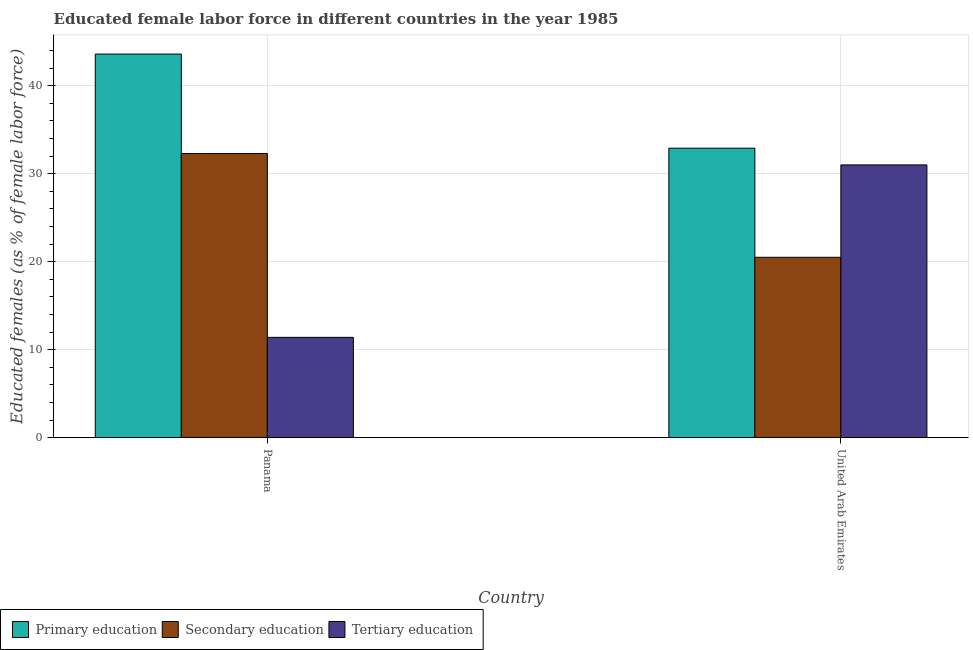How many different coloured bars are there?
Provide a short and direct response. 3. Are the number of bars on each tick of the X-axis equal?
Give a very brief answer. Yes. How many bars are there on the 1st tick from the right?
Ensure brevity in your answer.  3. What is the label of the 2nd group of bars from the left?
Give a very brief answer. United Arab Emirates. What is the percentage of female labor force who received primary education in United Arab Emirates?
Your answer should be very brief. 32.9. Across all countries, what is the maximum percentage of female labor force who received secondary education?
Your answer should be very brief. 32.3. Across all countries, what is the minimum percentage of female labor force who received tertiary education?
Provide a succinct answer. 11.4. In which country was the percentage of female labor force who received secondary education maximum?
Offer a very short reply. Panama. In which country was the percentage of female labor force who received primary education minimum?
Make the answer very short. United Arab Emirates. What is the total percentage of female labor force who received tertiary education in the graph?
Provide a succinct answer. 42.4. What is the difference between the percentage of female labor force who received tertiary education in Panama and that in United Arab Emirates?
Make the answer very short. -19.6. What is the difference between the percentage of female labor force who received secondary education in United Arab Emirates and the percentage of female labor force who received primary education in Panama?
Offer a terse response. -23.1. What is the average percentage of female labor force who received primary education per country?
Give a very brief answer. 38.25. In how many countries, is the percentage of female labor force who received primary education greater than 30 %?
Ensure brevity in your answer.  2. What is the ratio of the percentage of female labor force who received secondary education in Panama to that in United Arab Emirates?
Make the answer very short. 1.58. What does the 3rd bar from the left in United Arab Emirates represents?
Give a very brief answer. Tertiary education. What does the 2nd bar from the right in United Arab Emirates represents?
Provide a short and direct response. Secondary education. How many countries are there in the graph?
Offer a terse response. 2. What is the difference between two consecutive major ticks on the Y-axis?
Your answer should be compact. 10. Are the values on the major ticks of Y-axis written in scientific E-notation?
Ensure brevity in your answer.  No. Does the graph contain any zero values?
Offer a very short reply. No. Where does the legend appear in the graph?
Make the answer very short. Bottom left. How are the legend labels stacked?
Keep it short and to the point. Horizontal. What is the title of the graph?
Provide a short and direct response. Educated female labor force in different countries in the year 1985. What is the label or title of the Y-axis?
Your answer should be very brief. Educated females (as % of female labor force). What is the Educated females (as % of female labor force) in Primary education in Panama?
Your answer should be very brief. 43.6. What is the Educated females (as % of female labor force) of Secondary education in Panama?
Make the answer very short. 32.3. What is the Educated females (as % of female labor force) of Tertiary education in Panama?
Your answer should be very brief. 11.4. What is the Educated females (as % of female labor force) in Primary education in United Arab Emirates?
Your answer should be compact. 32.9. What is the Educated females (as % of female labor force) in Secondary education in United Arab Emirates?
Give a very brief answer. 20.5. What is the Educated females (as % of female labor force) in Tertiary education in United Arab Emirates?
Your answer should be compact. 31. Across all countries, what is the maximum Educated females (as % of female labor force) in Primary education?
Your answer should be very brief. 43.6. Across all countries, what is the maximum Educated females (as % of female labor force) in Secondary education?
Your answer should be very brief. 32.3. Across all countries, what is the maximum Educated females (as % of female labor force) of Tertiary education?
Your answer should be compact. 31. Across all countries, what is the minimum Educated females (as % of female labor force) in Primary education?
Offer a very short reply. 32.9. Across all countries, what is the minimum Educated females (as % of female labor force) of Tertiary education?
Offer a terse response. 11.4. What is the total Educated females (as % of female labor force) of Primary education in the graph?
Provide a succinct answer. 76.5. What is the total Educated females (as % of female labor force) of Secondary education in the graph?
Provide a short and direct response. 52.8. What is the total Educated females (as % of female labor force) in Tertiary education in the graph?
Ensure brevity in your answer.  42.4. What is the difference between the Educated females (as % of female labor force) in Tertiary education in Panama and that in United Arab Emirates?
Offer a terse response. -19.6. What is the difference between the Educated females (as % of female labor force) in Primary education in Panama and the Educated females (as % of female labor force) in Secondary education in United Arab Emirates?
Offer a very short reply. 23.1. What is the difference between the Educated females (as % of female labor force) in Secondary education in Panama and the Educated females (as % of female labor force) in Tertiary education in United Arab Emirates?
Offer a terse response. 1.3. What is the average Educated females (as % of female labor force) of Primary education per country?
Provide a short and direct response. 38.25. What is the average Educated females (as % of female labor force) of Secondary education per country?
Keep it short and to the point. 26.4. What is the average Educated females (as % of female labor force) in Tertiary education per country?
Your answer should be very brief. 21.2. What is the difference between the Educated females (as % of female labor force) in Primary education and Educated females (as % of female labor force) in Secondary education in Panama?
Offer a terse response. 11.3. What is the difference between the Educated females (as % of female labor force) of Primary education and Educated females (as % of female labor force) of Tertiary education in Panama?
Your response must be concise. 32.2. What is the difference between the Educated females (as % of female labor force) of Secondary education and Educated females (as % of female labor force) of Tertiary education in Panama?
Your answer should be very brief. 20.9. What is the difference between the Educated females (as % of female labor force) of Primary education and Educated females (as % of female labor force) of Tertiary education in United Arab Emirates?
Your response must be concise. 1.9. What is the difference between the Educated females (as % of female labor force) in Secondary education and Educated females (as % of female labor force) in Tertiary education in United Arab Emirates?
Provide a succinct answer. -10.5. What is the ratio of the Educated females (as % of female labor force) in Primary education in Panama to that in United Arab Emirates?
Your response must be concise. 1.33. What is the ratio of the Educated females (as % of female labor force) of Secondary education in Panama to that in United Arab Emirates?
Offer a very short reply. 1.58. What is the ratio of the Educated females (as % of female labor force) of Tertiary education in Panama to that in United Arab Emirates?
Provide a succinct answer. 0.37. What is the difference between the highest and the second highest Educated females (as % of female labor force) of Primary education?
Provide a succinct answer. 10.7. What is the difference between the highest and the second highest Educated females (as % of female labor force) of Secondary education?
Your answer should be compact. 11.8. What is the difference between the highest and the second highest Educated females (as % of female labor force) of Tertiary education?
Provide a succinct answer. 19.6. What is the difference between the highest and the lowest Educated females (as % of female labor force) in Primary education?
Your answer should be compact. 10.7. What is the difference between the highest and the lowest Educated females (as % of female labor force) in Tertiary education?
Your answer should be very brief. 19.6. 